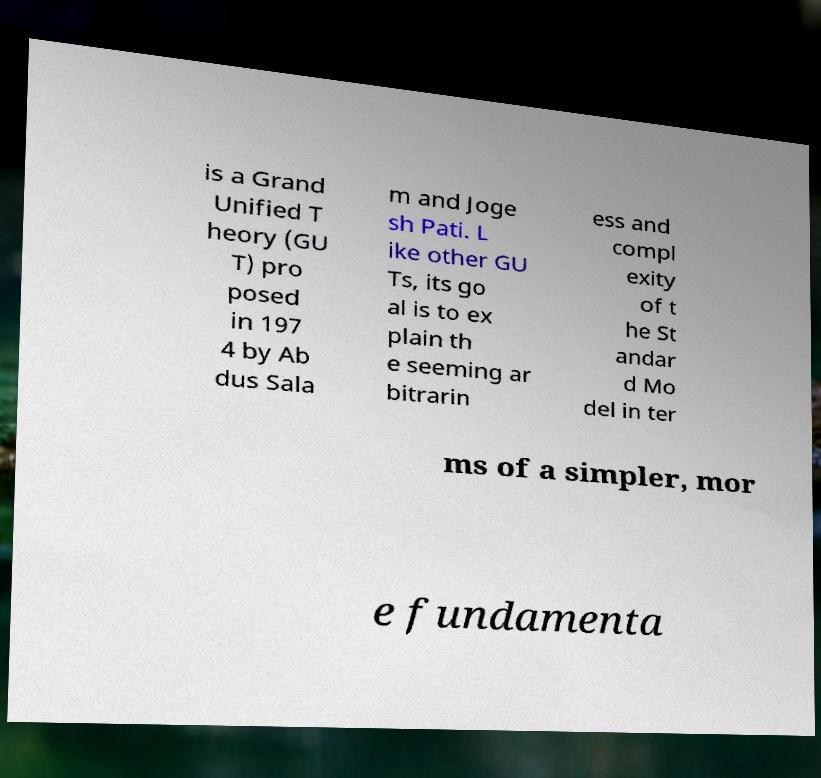Could you extract and type out the text from this image? is a Grand Unified T heory (GU T) pro posed in 197 4 by Ab dus Sala m and Joge sh Pati. L ike other GU Ts, its go al is to ex plain th e seeming ar bitrarin ess and compl exity of t he St andar d Mo del in ter ms of a simpler, mor e fundamenta 